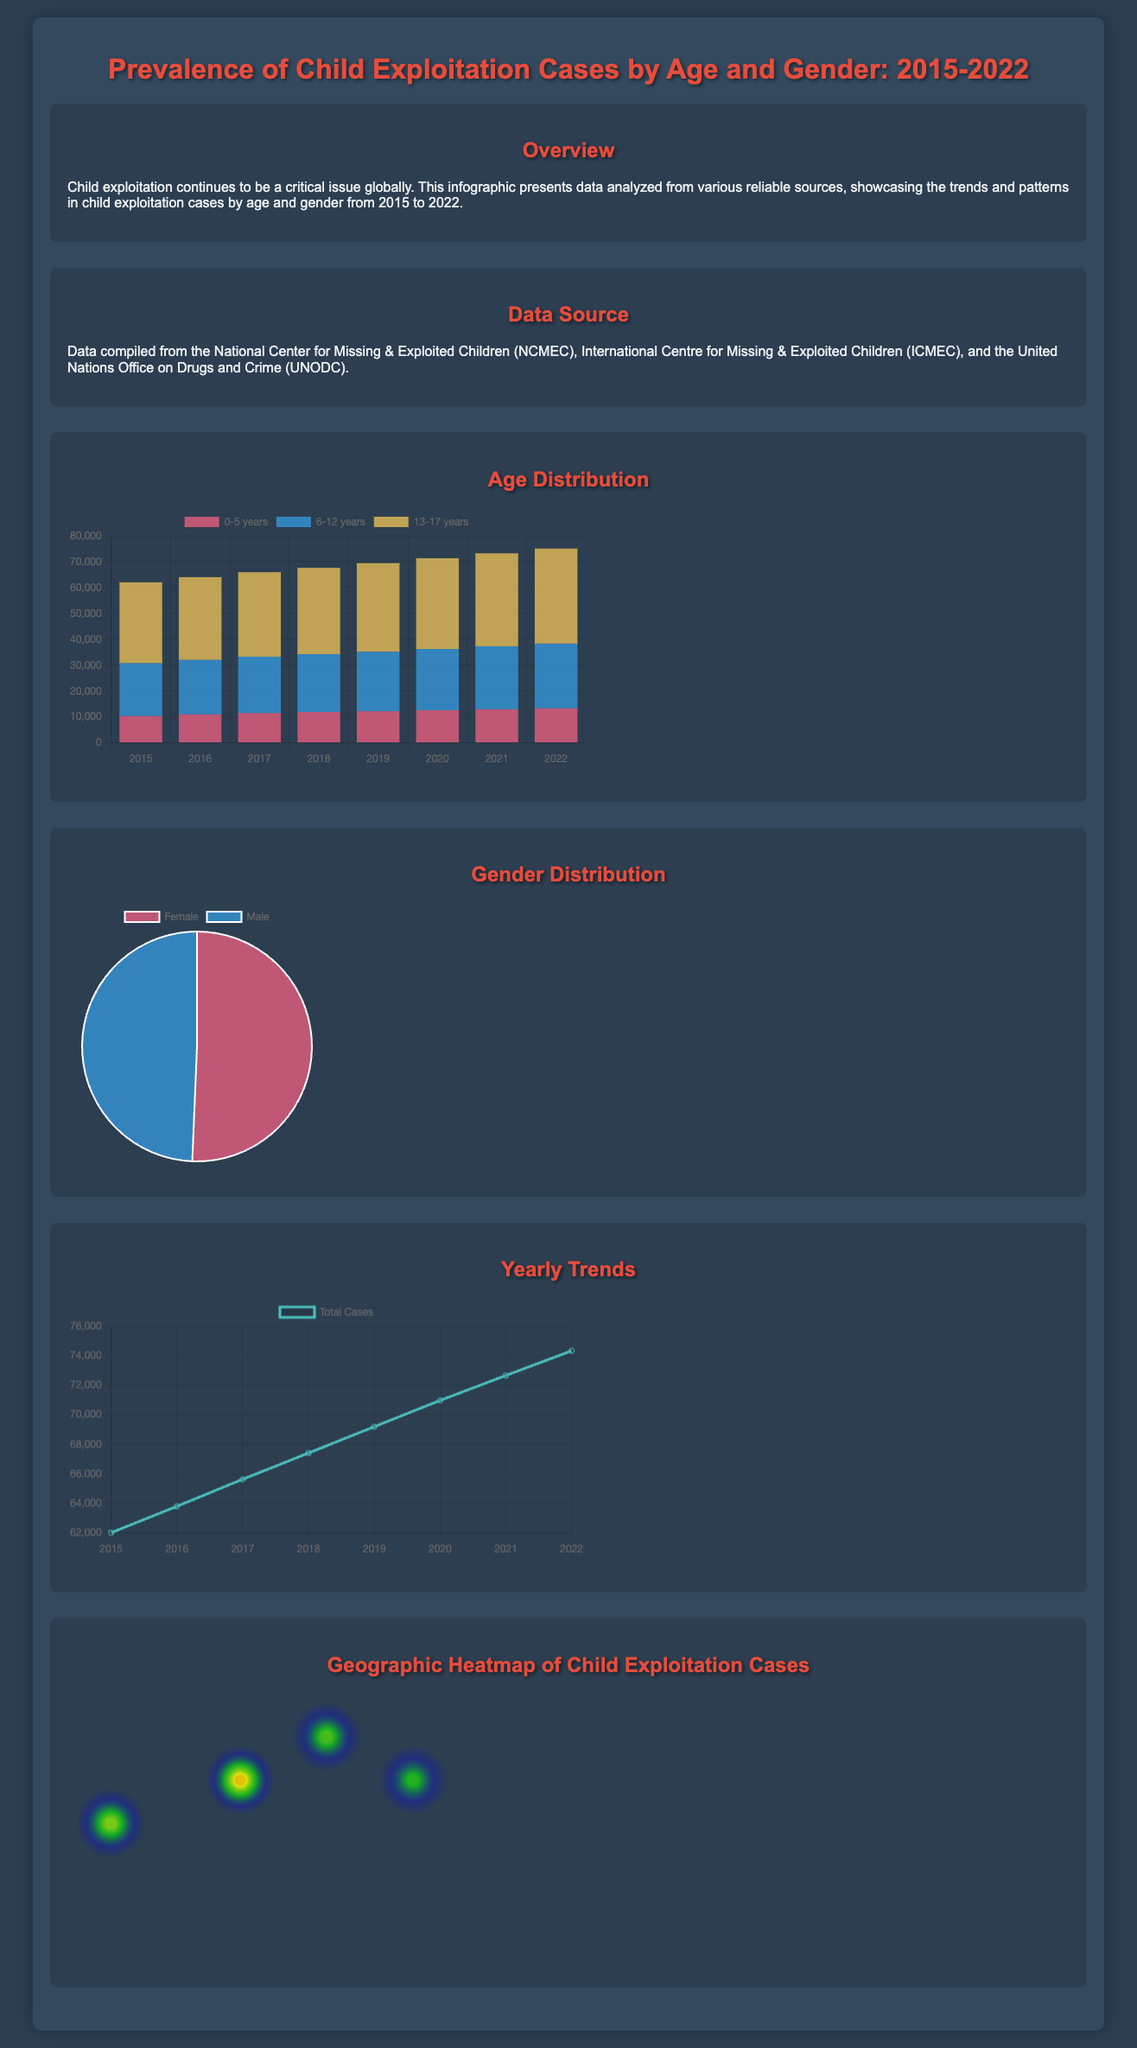What is the total number of child exploitation cases in 2022? The total number of child exploitation cases in 2022 is noted in the yearly trends chart, which shows 74324 cases.
Answer: 74324 What age group had the highest number of cases in 2020? The age distribution chart displays data by age group for 2020, where the 13-17 years group has the highest cases at 35087.
Answer: 13-17 years How many cases were reported for the 0-5 years age group in 2018? The age distribution chart provides specific numbers, showing 11876 cases for the 0-5 years age group in 2018.
Answer: 11876 What was the percentage distribution of male child exploitation cases? The gender distribution pie chart indicates that male child exploitation cases accounted for approximately 49.3% of total cases, based on counts.
Answer: 49.3% Which year saw the lowest total number of child exploitation cases? The yearly trends chart shows that 2015 had the lowest total with 62024 cases compared to subsequent years.
Answer: 2015 Which city had the highest value on the heatmap? The heatmap points show that New York had the highest value with 8792 cases of child exploitation.
Answer: New York What was the total number of female child exploitation cases reported? The gender distribution indicates that there were 277312 female cases reported according to the dataset.
Answer: 277312 What was the observed trend for total cases from 2015 to 2022? The trend chart demonstrates that total cases have steadily increased each year from 62024 in 2015 to 74324 in 2022.
Answer: Steady increase How many cases were recorded in the 6-12 years age group in 2019? According to the age distribution chart, there were 23001 cases recorded for the 6-12 years age group in 2019.
Answer: 23001 